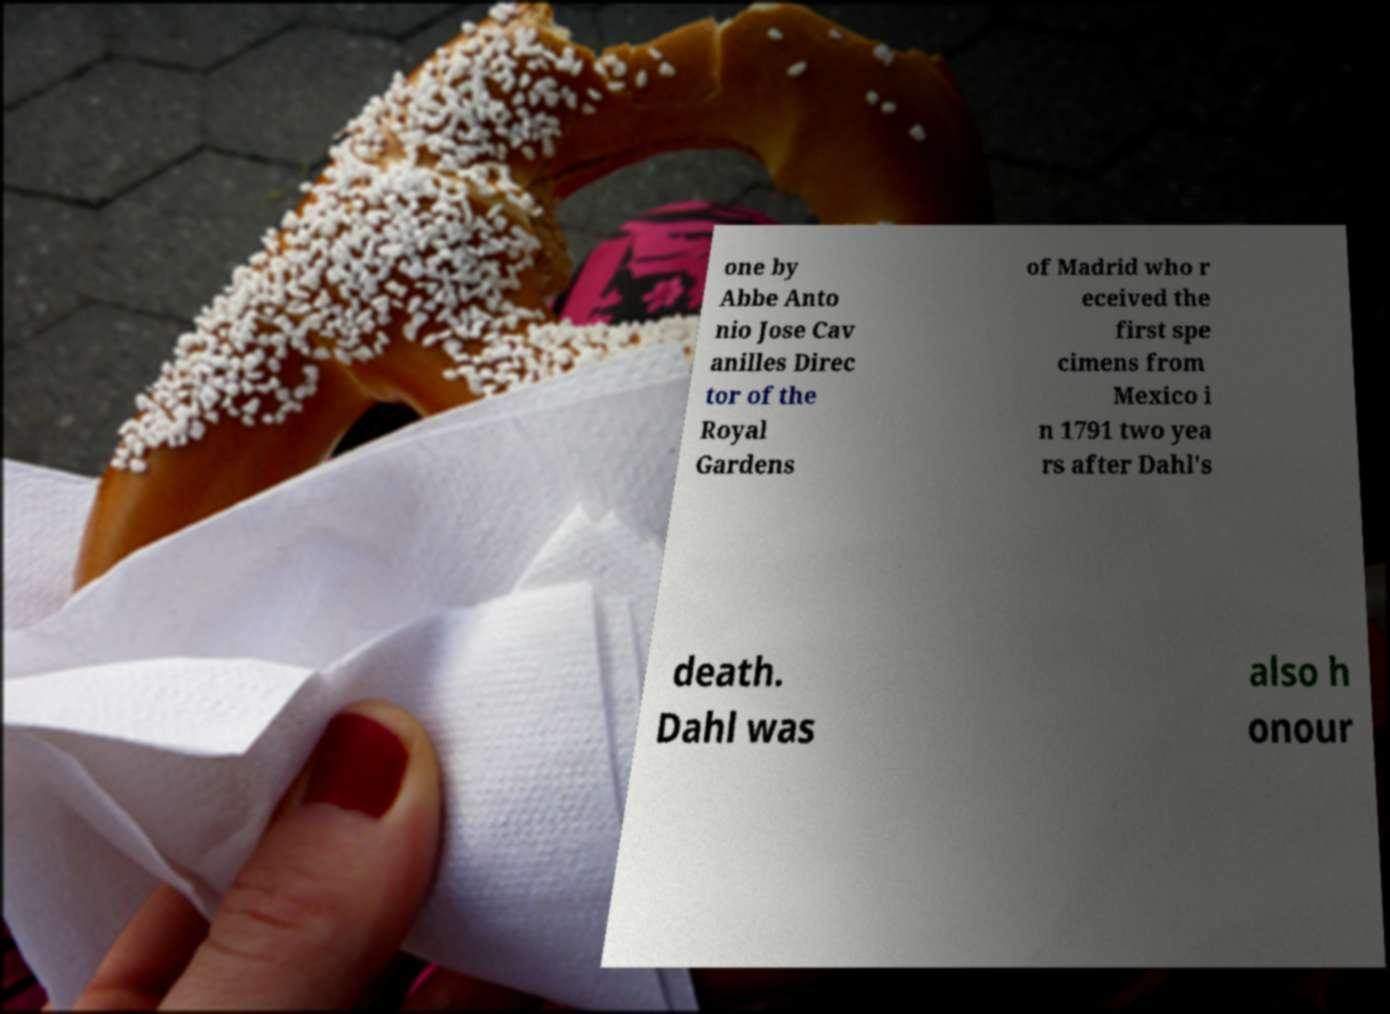Please identify and transcribe the text found in this image. one by Abbe Anto nio Jose Cav anilles Direc tor of the Royal Gardens of Madrid who r eceived the first spe cimens from Mexico i n 1791 two yea rs after Dahl's death. Dahl was also h onour 